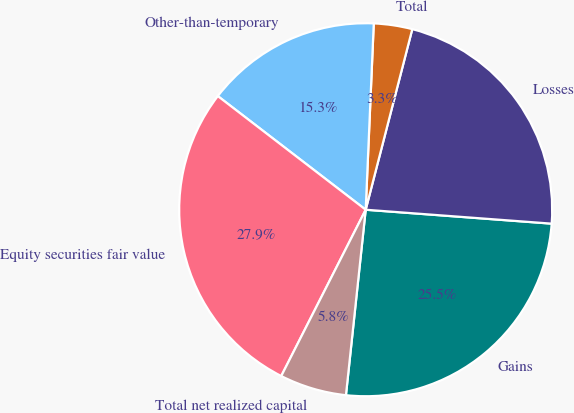Convert chart to OTSL. <chart><loc_0><loc_0><loc_500><loc_500><pie_chart><fcel>Gains<fcel>Losses<fcel>Total<fcel>Other-than-temporary<fcel>Equity securities fair value<fcel>Total net realized capital<nl><fcel>25.5%<fcel>22.17%<fcel>3.33%<fcel>15.26%<fcel>27.95%<fcel>5.79%<nl></chart> 